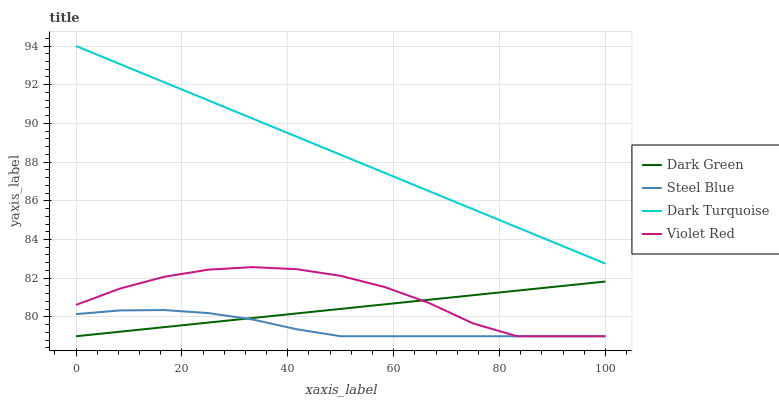Does Steel Blue have the minimum area under the curve?
Answer yes or no. Yes. Does Dark Turquoise have the maximum area under the curve?
Answer yes or no. Yes. Does Violet Red have the minimum area under the curve?
Answer yes or no. No. Does Violet Red have the maximum area under the curve?
Answer yes or no. No. Is Dark Turquoise the smoothest?
Answer yes or no. Yes. Is Violet Red the roughest?
Answer yes or no. Yes. Is Steel Blue the smoothest?
Answer yes or no. No. Is Steel Blue the roughest?
Answer yes or no. No. Does Violet Red have the lowest value?
Answer yes or no. Yes. Does Dark Turquoise have the highest value?
Answer yes or no. Yes. Does Violet Red have the highest value?
Answer yes or no. No. Is Violet Red less than Dark Turquoise?
Answer yes or no. Yes. Is Dark Turquoise greater than Dark Green?
Answer yes or no. Yes. Does Violet Red intersect Steel Blue?
Answer yes or no. Yes. Is Violet Red less than Steel Blue?
Answer yes or no. No. Is Violet Red greater than Steel Blue?
Answer yes or no. No. Does Violet Red intersect Dark Turquoise?
Answer yes or no. No. 